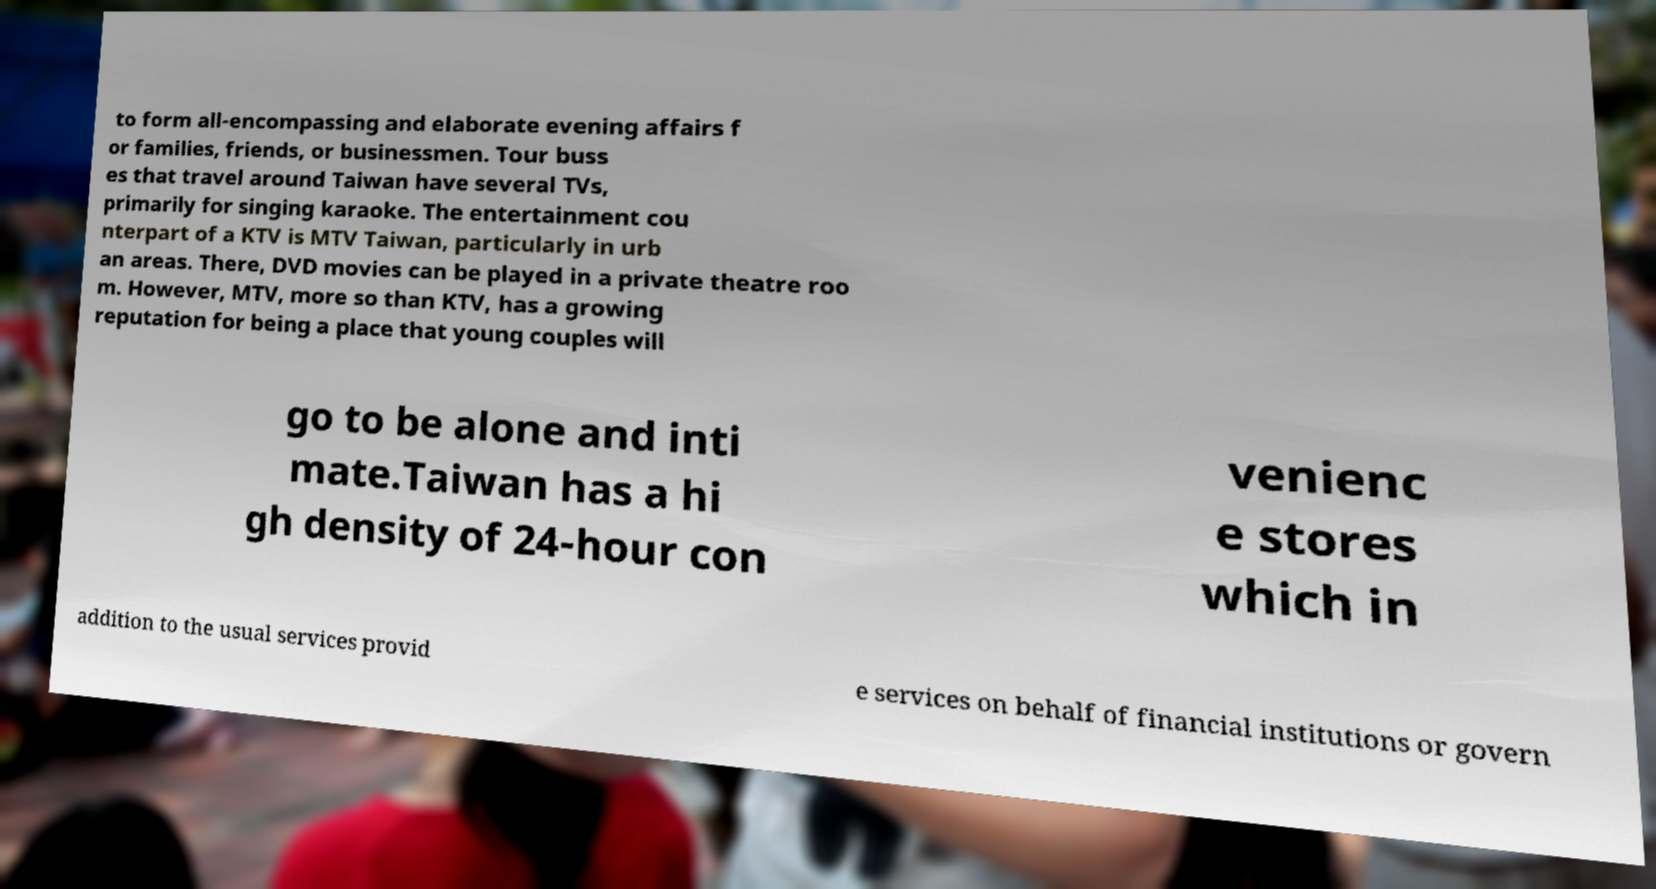Can you read and provide the text displayed in the image?This photo seems to have some interesting text. Can you extract and type it out for me? to form all-encompassing and elaborate evening affairs f or families, friends, or businessmen. Tour buss es that travel around Taiwan have several TVs, primarily for singing karaoke. The entertainment cou nterpart of a KTV is MTV Taiwan, particularly in urb an areas. There, DVD movies can be played in a private theatre roo m. However, MTV, more so than KTV, has a growing reputation for being a place that young couples will go to be alone and inti mate.Taiwan has a hi gh density of 24-hour con venienc e stores which in addition to the usual services provid e services on behalf of financial institutions or govern 